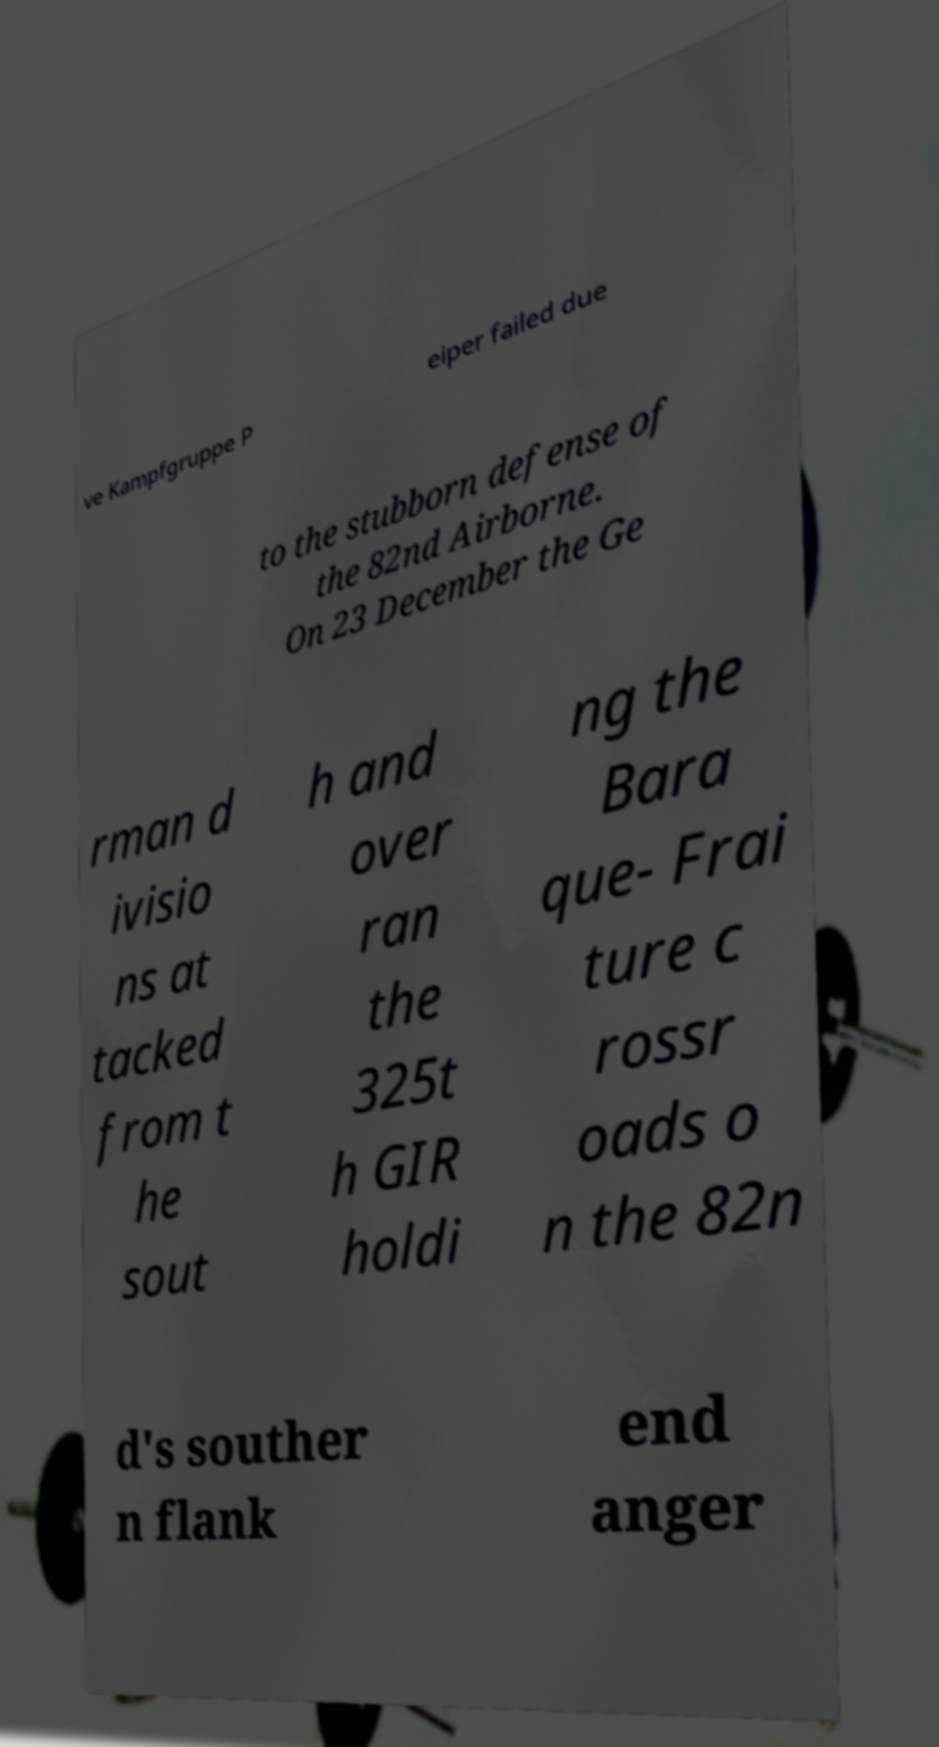Please read and relay the text visible in this image. What does it say? ve Kampfgruppe P eiper failed due to the stubborn defense of the 82nd Airborne. On 23 December the Ge rman d ivisio ns at tacked from t he sout h and over ran the 325t h GIR holdi ng the Bara que- Frai ture c rossr oads o n the 82n d's souther n flank end anger 